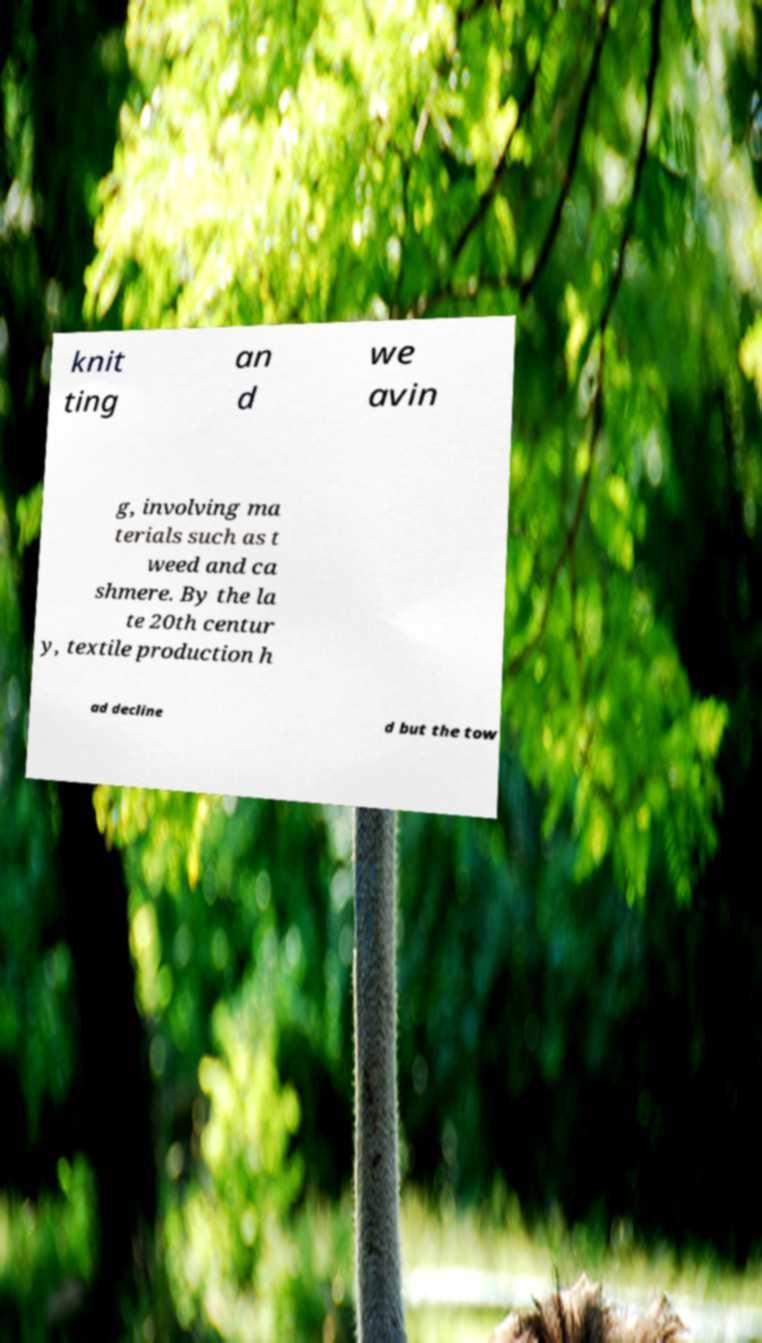What messages or text are displayed in this image? I need them in a readable, typed format. knit ting an d we avin g, involving ma terials such as t weed and ca shmere. By the la te 20th centur y, textile production h ad decline d but the tow 